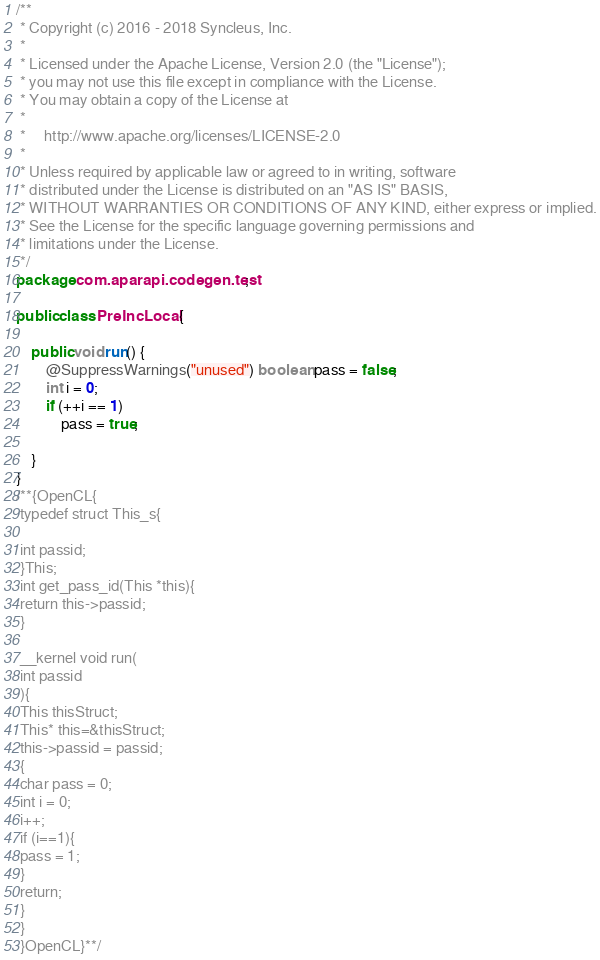<code> <loc_0><loc_0><loc_500><loc_500><_Java_>/**
 * Copyright (c) 2016 - 2018 Syncleus, Inc.
 *
 * Licensed under the Apache License, Version 2.0 (the "License");
 * you may not use this file except in compliance with the License.
 * You may obtain a copy of the License at
 *
 *     http://www.apache.org/licenses/LICENSE-2.0
 *
 * Unless required by applicable law or agreed to in writing, software
 * distributed under the License is distributed on an "AS IS" BASIS,
 * WITHOUT WARRANTIES OR CONDITIONS OF ANY KIND, either express or implied.
 * See the License for the specific language governing permissions and
 * limitations under the License.
 */
package com.aparapi.codegen.test;

public class PreIncLocal {

    public void run() {
        @SuppressWarnings("unused") boolean pass = false;
        int i = 0;
        if (++i == 1)
            pass = true;

    }
}
/**{OpenCL{
 typedef struct This_s{

 int passid;
 }This;
 int get_pass_id(This *this){
 return this->passid;
 }

 __kernel void run(
 int passid
 ){
 This thisStruct;
 This* this=&thisStruct;
 this->passid = passid;
 {
 char pass = 0;
 int i = 0;
 i++;
 if (i==1){
 pass = 1;
 }
 return;
 }
 }
 }OpenCL}**/
</code> 